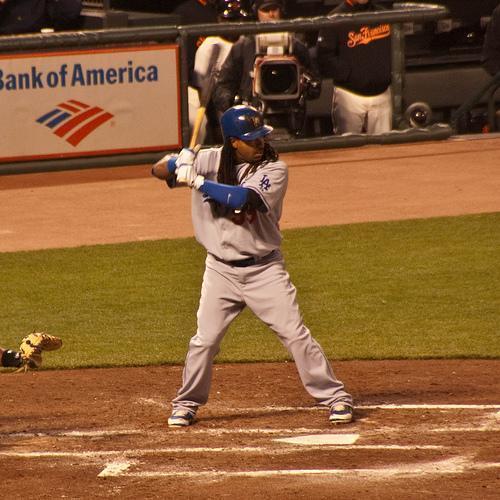How many players in photo?
Give a very brief answer. 1. 